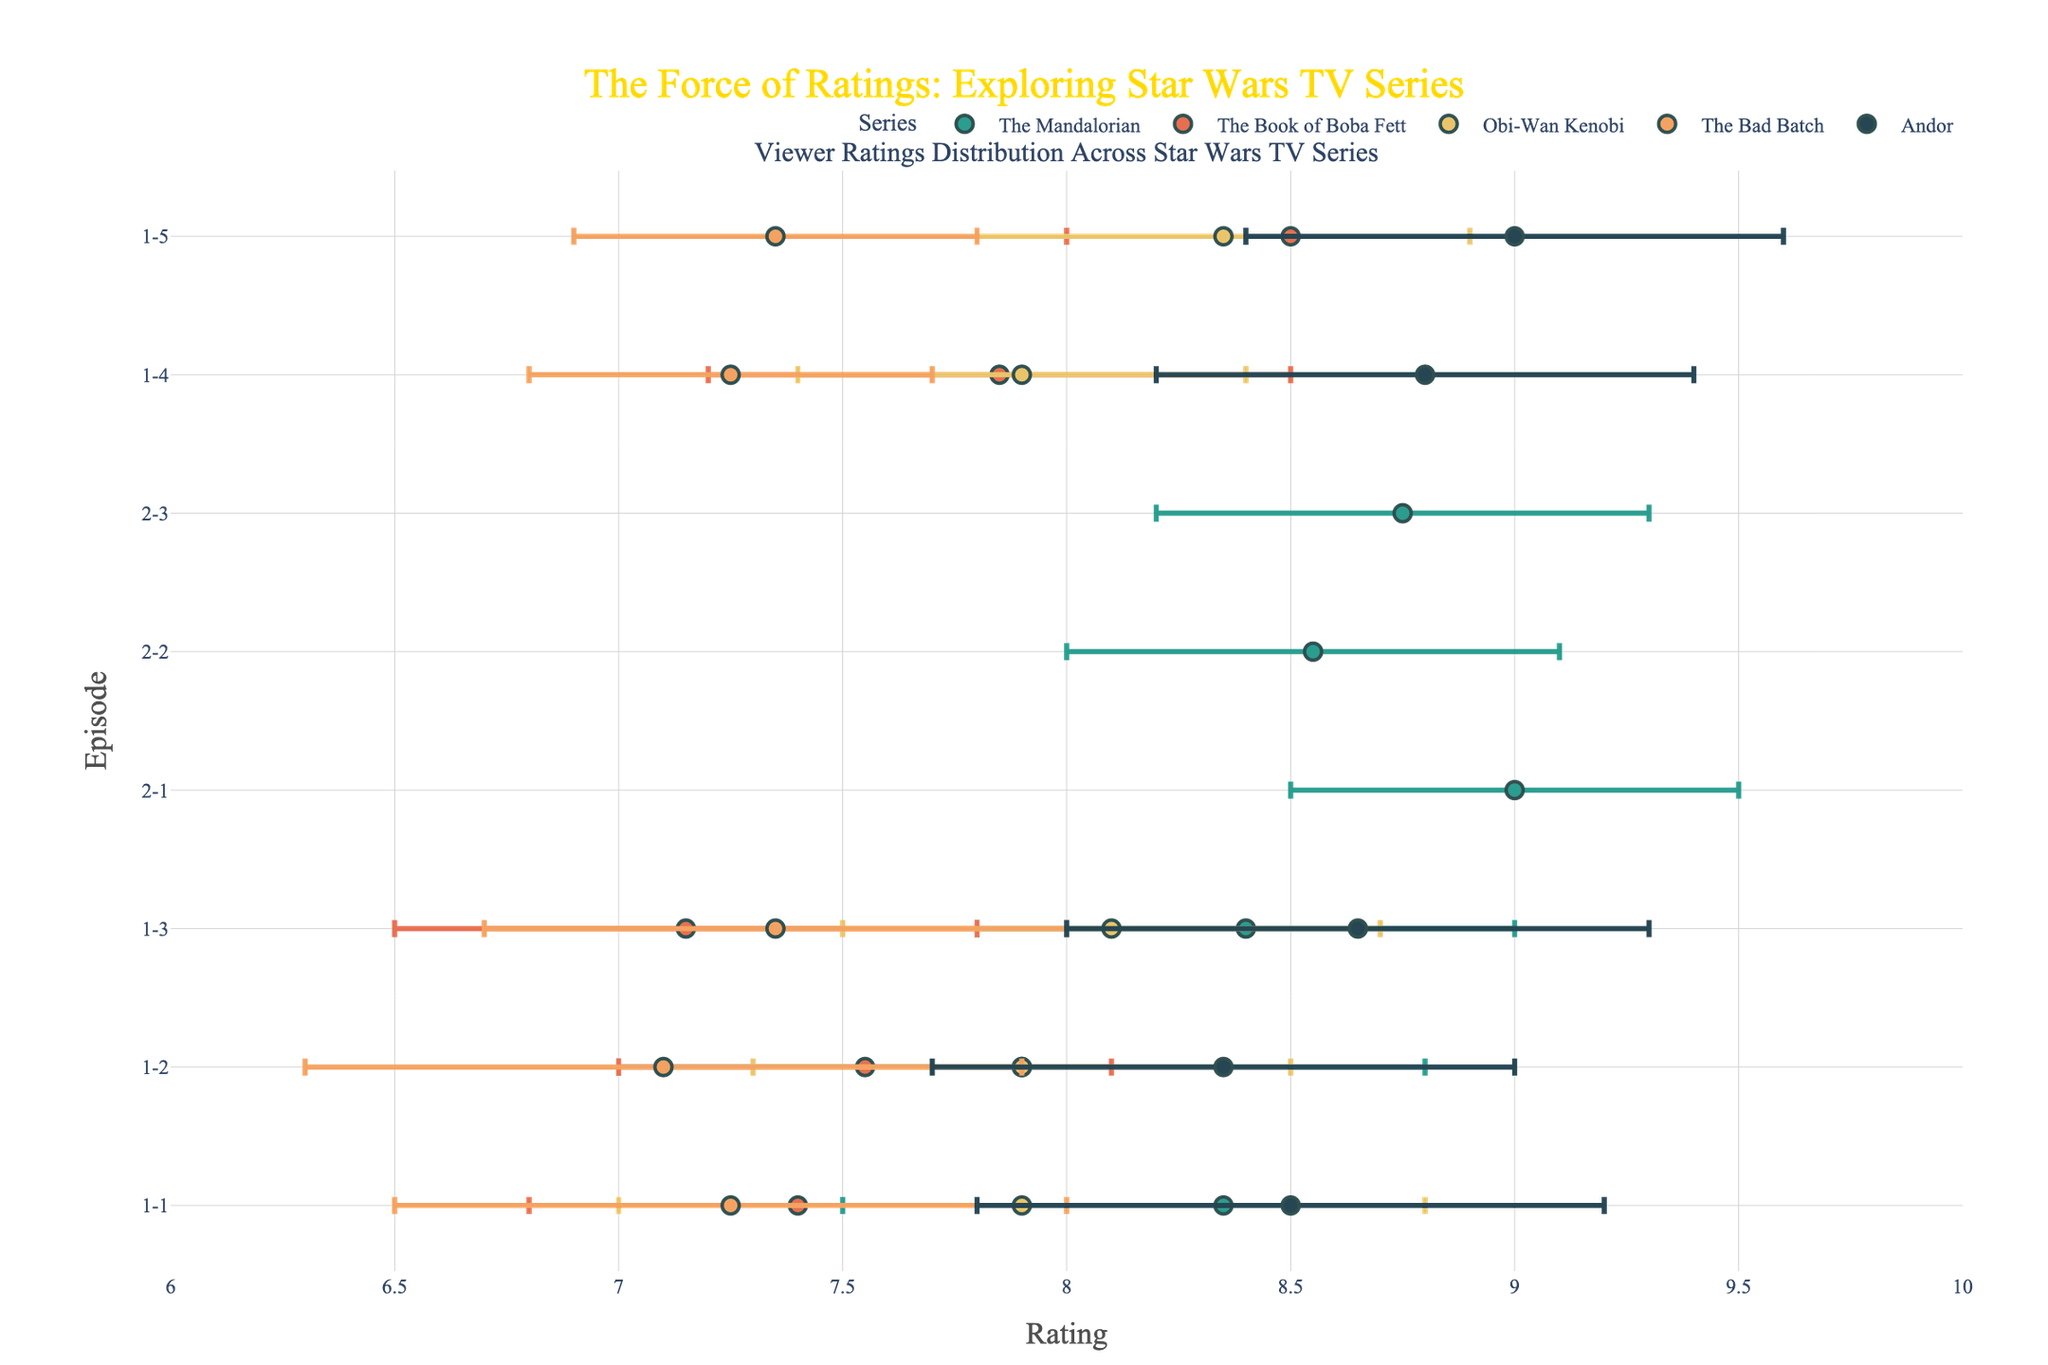what is the title of the plot? The title is found at the top of the figure, and it reads "The Force of Ratings: Exploring Star Wars TV Series," rendered in a large font.
Answer: The Force of Ratings: Exploring Star Wars TV Series which series has the widest rating range for any episode? By examining the error bars' horizontal length, "The Book of Boba Fett" episode 3 features the widest range.
Answer: The Book of Boba Fett what is the highest average rating observed in any series, and which episode is it? Average rating is the midpoint of the mean rating. "Andor" episode 5 has the highest average score of 9.0, calculated as (8.4 + 9.6) / 2.
Answer: 9.0, Andor episode 5 how does the average rating for "The Mandalorian" season 2, episode 1 compare to "Obi-Wan Kenobi" season 1, episode 5? Extract mean ratings from error bars. "The Mandalorian" season 2, episode 1: (8.5 + 9.5) / 2 = 9.0. "Obi-Wan Kenobi" season 1, episode 5: (7.8 + 8.9) / 2 = 8.35. "The Mandalorian" has a higher average rating.
Answer: The Mandalorian season 2, episode 1: 9.0, higher than Obi-Wan Kenobi season 1, episode 5: 8.35 which episode in "The Bad Batch" has the smallest rating range, and what are the min and max ratings for that episode? By examining error bars, "The Bad Batch" episode 5 has the smallest range with min 6.9 and max 7.8, providing the smallest difference.
Answer: Episode 5, Min: 6.9, Max: 7.8 are there any episodes with a max rating higher than the entire "The Book of Boba Fett" series? Look for max ratings across series. "The Mandalorian" and "Andor" have episodes exceeding "The Book of Boba Fett's" highest rating (9.0) in episodes from season 2 and all 5 episodes of "Andor" with max rating 9.2+
Answer: Yes, episodes from "The Mandalorian" season 2 and "Andor" what rating range does "The Mandalorian" season 1, episode 1 fall into, and how does this relate to other episodes from the same season? Determine "The Mandalorian" season 1, episode 1's rating (7.5 to 9.2). Compare ranges with other season 1 episodes, identifying similar spans.
Answer: 7.5 to 9.2, broader than most episodes in the same season if a new episode in "The Bad Batch" was released with more than 1.5 rating range, violated the range observed in current episodes? Identify the max allowed range. All other "Bad Batch" episodes maintain a ≤ 1.5 range. A new episode > 1.5 breaks this trend.
Answer: Yes, it would violate what is the average rating range for "Obi-Wan Kenobi"? Identify ranges and complete arithmetic operations for each episode ((8.8-7.0) + (8.5-7.3) + (8.7-7.5) + (8.4-7.4) + (8.9-7.8)) / 5 = ((1.8+1.2+1.2+1.0+1.1) / 5) = 1.26
Answer: 1.26 